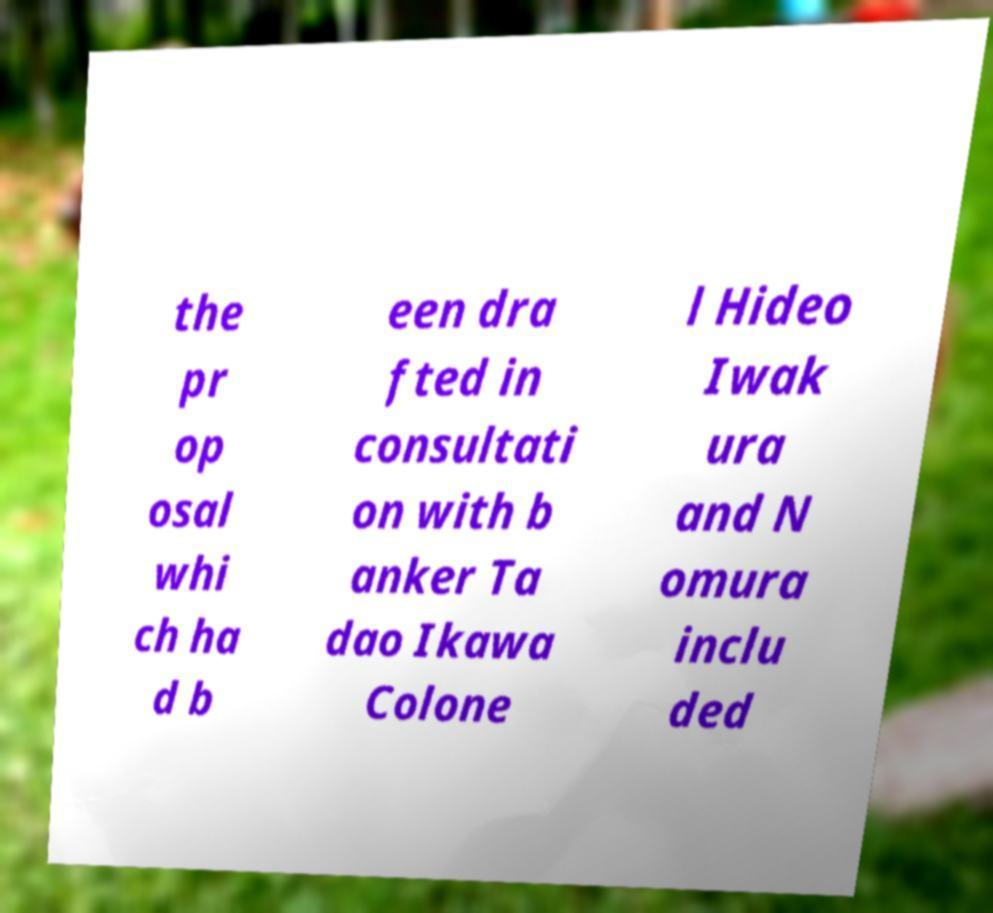What messages or text are displayed in this image? I need them in a readable, typed format. the pr op osal whi ch ha d b een dra fted in consultati on with b anker Ta dao Ikawa Colone l Hideo Iwak ura and N omura inclu ded 